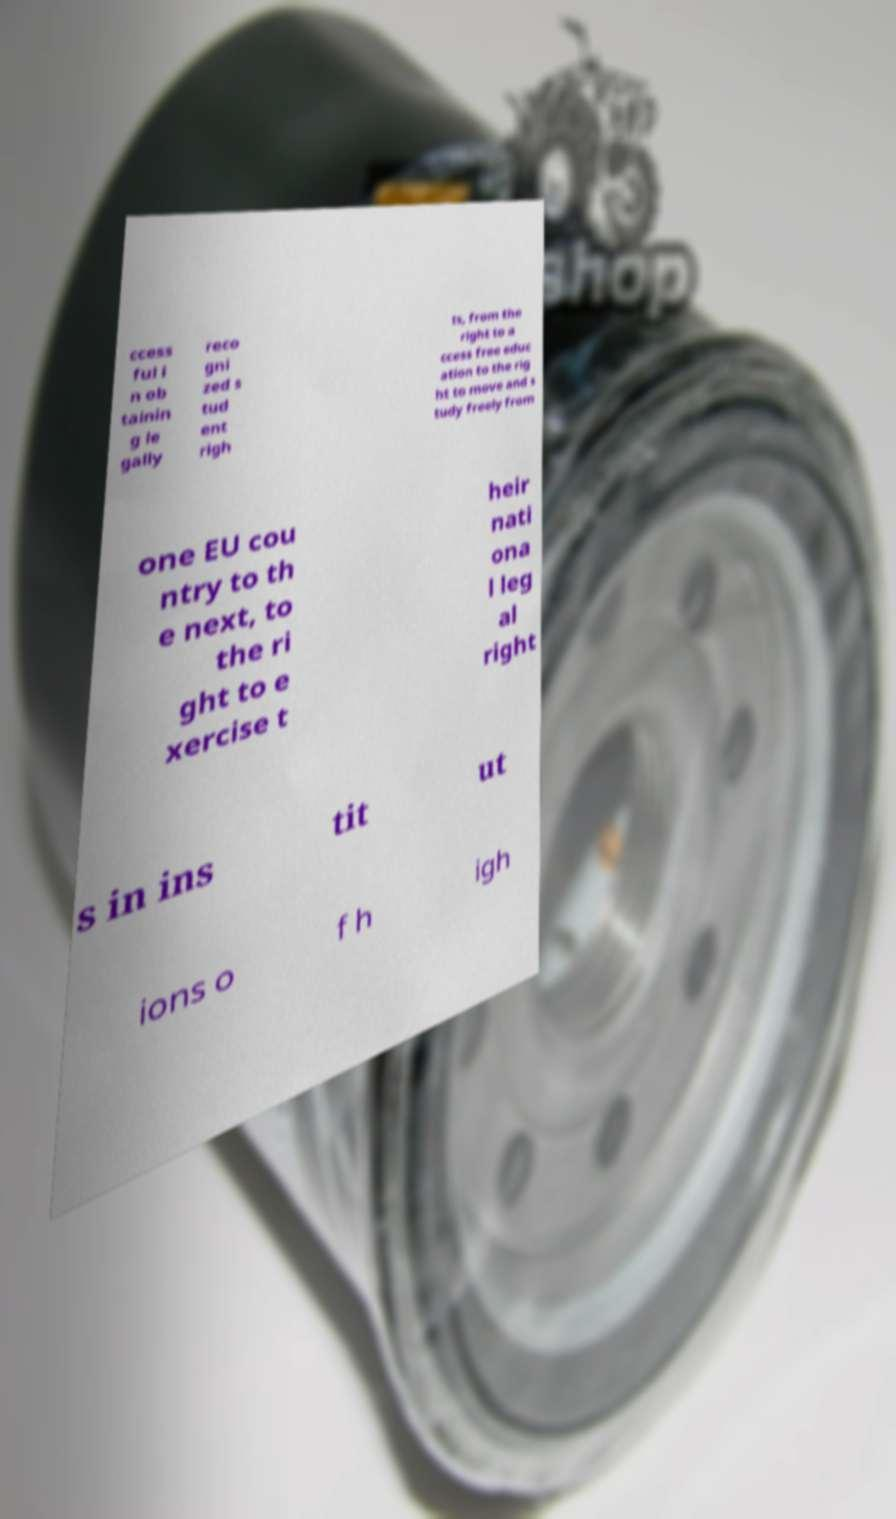Can you read and provide the text displayed in the image?This photo seems to have some interesting text. Can you extract and type it out for me? ccess ful i n ob tainin g le gally reco gni zed s tud ent righ ts, from the right to a ccess free educ ation to the rig ht to move and s tudy freely from one EU cou ntry to th e next, to the ri ght to e xercise t heir nati ona l leg al right s in ins tit ut ions o f h igh 